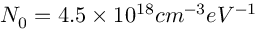Convert formula to latex. <formula><loc_0><loc_0><loc_500><loc_500>N _ { 0 } = 4 . 5 \times 1 0 ^ { 1 8 } c m ^ { - 3 } e V ^ { - 1 }</formula> 